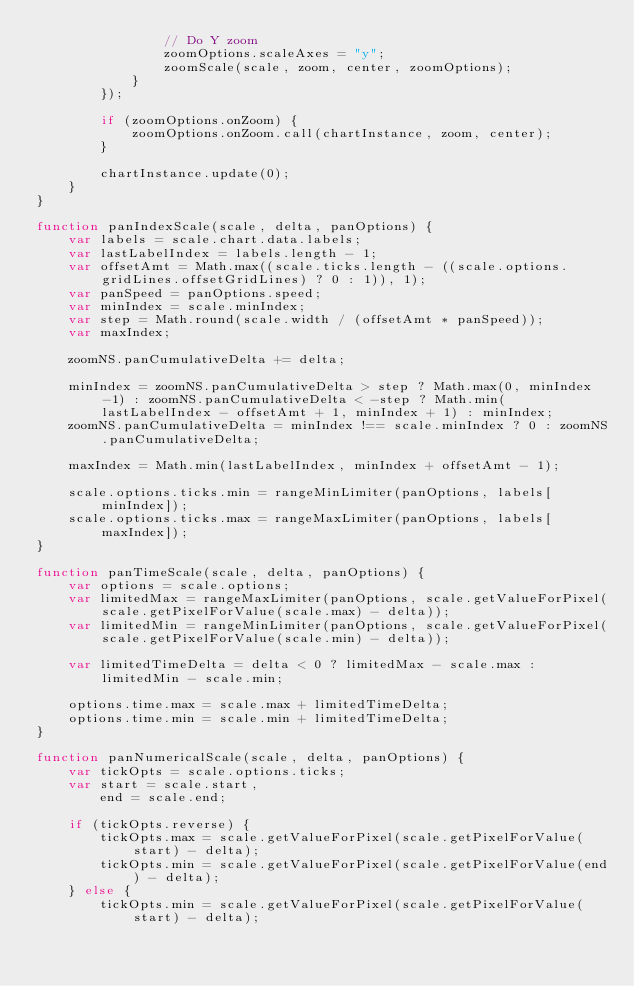<code> <loc_0><loc_0><loc_500><loc_500><_JavaScript_>				// Do Y zoom
				zoomOptions.scaleAxes = "y";
				zoomScale(scale, zoom, center, zoomOptions);
			}
		});

		if (zoomOptions.onZoom) {
			zoomOptions.onZoom.call(chartInstance, zoom, center);
		}

		chartInstance.update(0);
	}
}

function panIndexScale(scale, delta, panOptions) {
	var labels = scale.chart.data.labels;
	var lastLabelIndex = labels.length - 1;
	var offsetAmt = Math.max((scale.ticks.length - ((scale.options.gridLines.offsetGridLines) ? 0 : 1)), 1);
	var panSpeed = panOptions.speed;
	var minIndex = scale.minIndex;
	var step = Math.round(scale.width / (offsetAmt * panSpeed));
	var maxIndex;

	zoomNS.panCumulativeDelta += delta;

	minIndex = zoomNS.panCumulativeDelta > step ? Math.max(0, minIndex -1) : zoomNS.panCumulativeDelta < -step ? Math.min(lastLabelIndex - offsetAmt + 1, minIndex + 1) : minIndex;
	zoomNS.panCumulativeDelta = minIndex !== scale.minIndex ? 0 : zoomNS.panCumulativeDelta;

	maxIndex = Math.min(lastLabelIndex, minIndex + offsetAmt - 1);

	scale.options.ticks.min = rangeMinLimiter(panOptions, labels[minIndex]);
	scale.options.ticks.max = rangeMaxLimiter(panOptions, labels[maxIndex]);
}

function panTimeScale(scale, delta, panOptions) {
	var options = scale.options;
	var limitedMax = rangeMaxLimiter(panOptions, scale.getValueForPixel(scale.getPixelForValue(scale.max) - delta));
	var limitedMin = rangeMinLimiter(panOptions, scale.getValueForPixel(scale.getPixelForValue(scale.min) - delta));

	var limitedTimeDelta = delta < 0 ? limitedMax - scale.max : limitedMin - scale.min;

	options.time.max = scale.max + limitedTimeDelta;
	options.time.min = scale.min + limitedTimeDelta;
}

function panNumericalScale(scale, delta, panOptions) {
	var tickOpts = scale.options.ticks;
	var start = scale.start,
		end = scale.end;

	if (tickOpts.reverse) {
		tickOpts.max = scale.getValueForPixel(scale.getPixelForValue(start) - delta);
		tickOpts.min = scale.getValueForPixel(scale.getPixelForValue(end) - delta);
	} else {
		tickOpts.min = scale.getValueForPixel(scale.getPixelForValue(start) - delta);</code> 